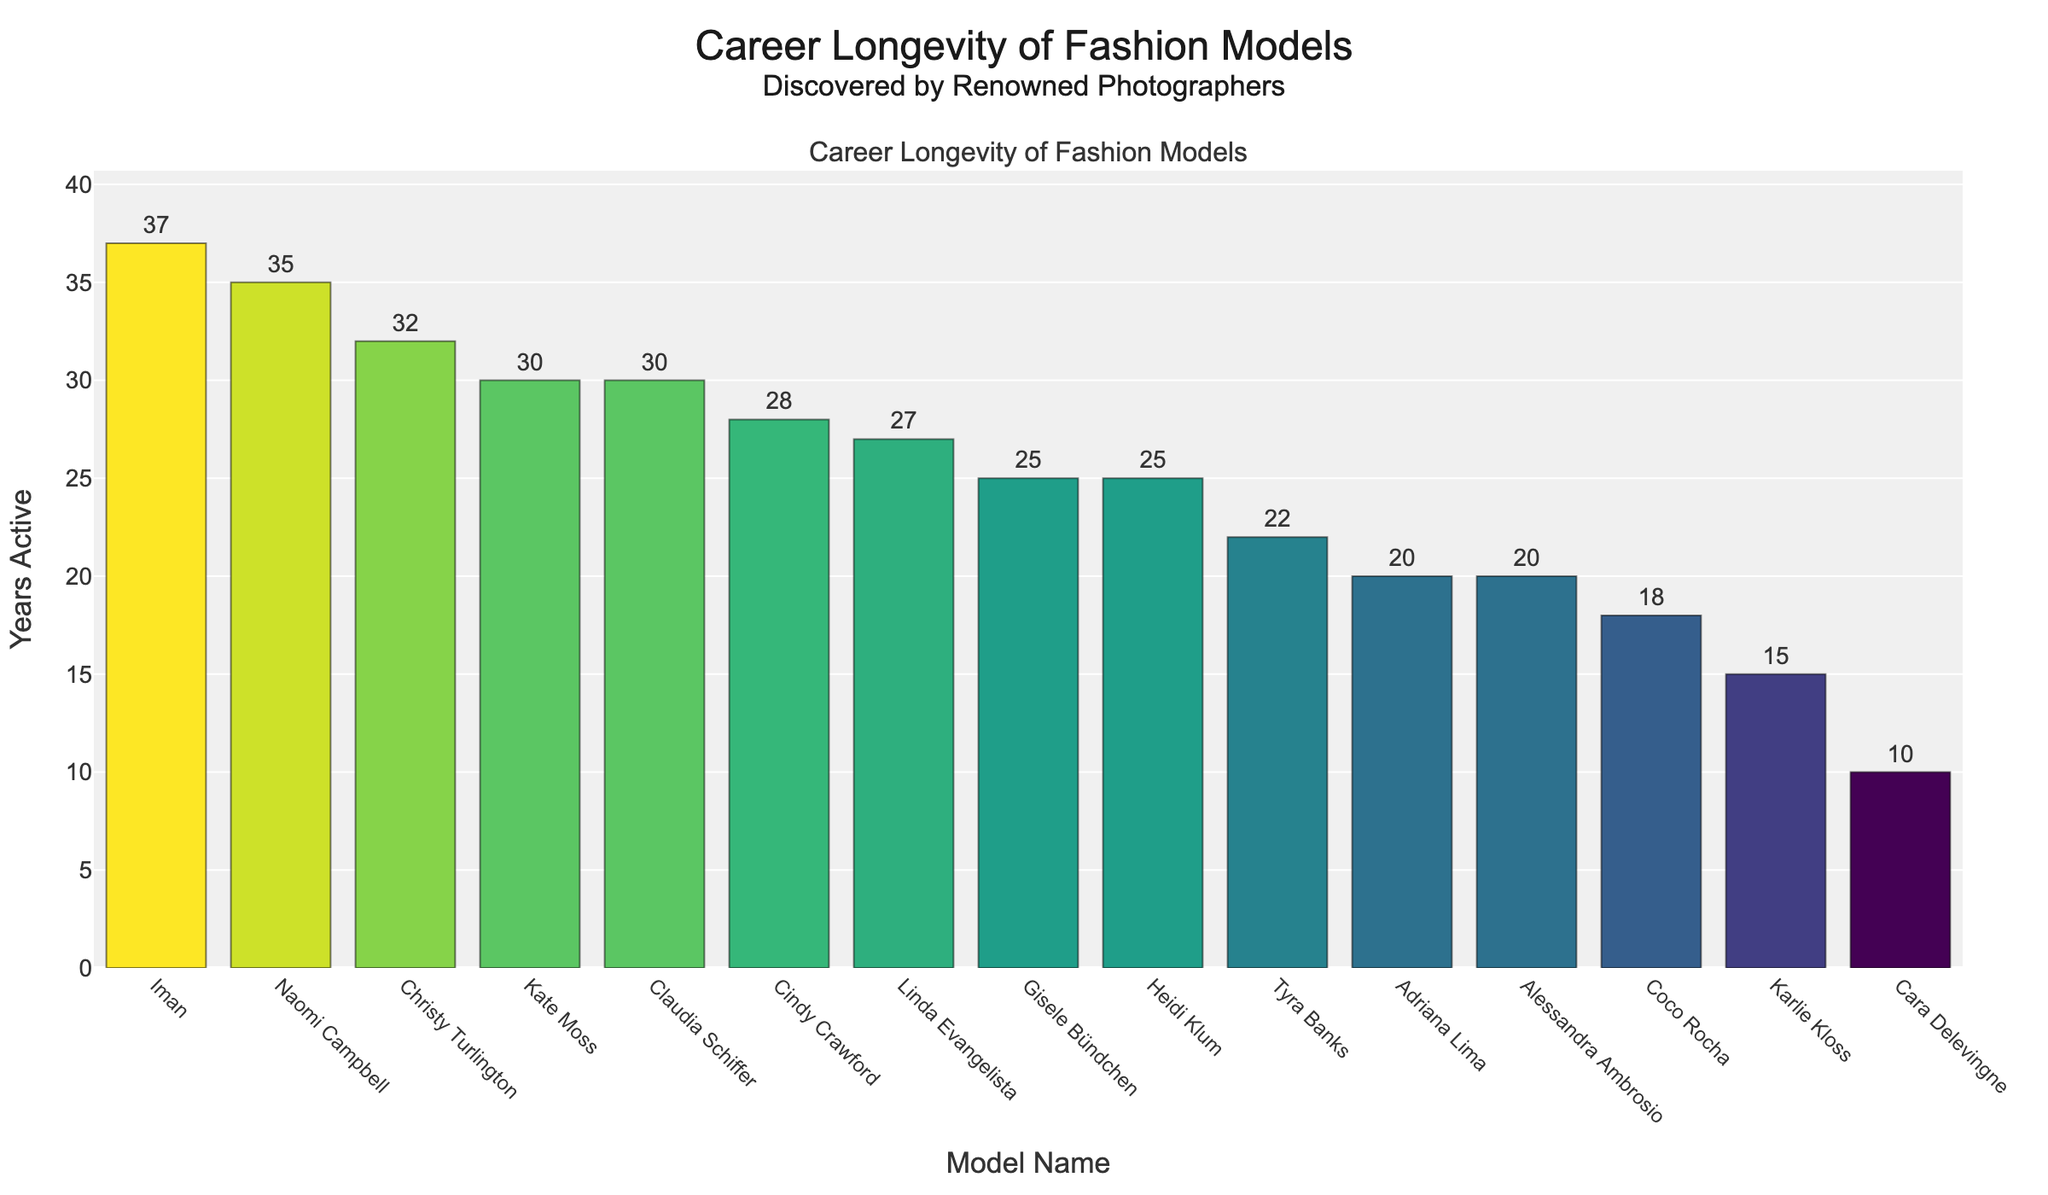Which model has the longest career longevity according to the chart? Naomi Campbell has the longest career longevity of 35 years as indicated by the tallest bar.
Answer: Naomi Campbell Which model was discovered by Mario Testino and how long was their career? Mario Testino discovered two models: Gisele Bündchen and Cara Delevingne. Gisele Bündchen had a career spanning 25 years, and Cara Delevingne had a career of 10 years.
Answer: Gisele Bündchen (25 years), Cara Delevingne (10 years) Who discovered the model with a 30-year career named Claudia Schiffer? Claudia Schiffer, with a career span of 30 years, was discovered by Ellen von Unwerth as indicated by the hover information.
Answer: Ellen von Unwerth What is the total career longevity of models discovered by Steven Meisel? Steven Meisel discovered Adriana Lima (20 years) and Coco Rocha (18 years). Summing their career years: 20 + 18 = 38 years.
Answer: 38 years Compare the career longevity of models discovered by Ellen von Unwerth and Peter Lindbergh. Who has more total years? Ellen von Unwerth discovered Claudia Schiffer (30 years) and Alessandra Ambrosio (20 years), totaling 50 years. Peter Lindbergh discovered Linda Evangelista with 27 years. 50 years is more than 27 years.
Answer: Ellen von Unwerth Which photographer discovered the model with the shortest career, and how many years was it? The model with the shortest career is Cara Delevingne with 10 years. She was discovered by Mario Testino as indicated by the hover information.
Answer: Mario Testino How many models have had careers spanning 30 years or more? Models with careers 30 years or more are Claudia Schiffer (30), Kate Moss (30), Christy Turlington (32), Naomi Campbell (35), and Iman (37). There are 5 such models.
Answer: 5 What is the average career longevity of the models discovered by Corinne Day and Patrick Demarchelier combined? Corinne Day discovered Kate Moss (30 years) and Patrick Demarchelier discovered Naomi Campbell (35 years). Mean = (30 + 35) / 2 = 32.5 years.
Answer: 32.5 years Which model discovered by Arthur Elgort and one discovered by Victor Skrebneski had similar career lengths? Arthur Elgort discovered Christy Turlington (32 years) and Victor Skrebneski discovered Cindy Crawford (28 years). Their career longevities are quite close.
Answer: Christy Turlington and Cindy Crawford How does the bar color change in relation to years active for the models? The bar colors change from lighter to darker shades as the years active increase, creating a gradient effect.
Answer: Darker bars indicate more years active 